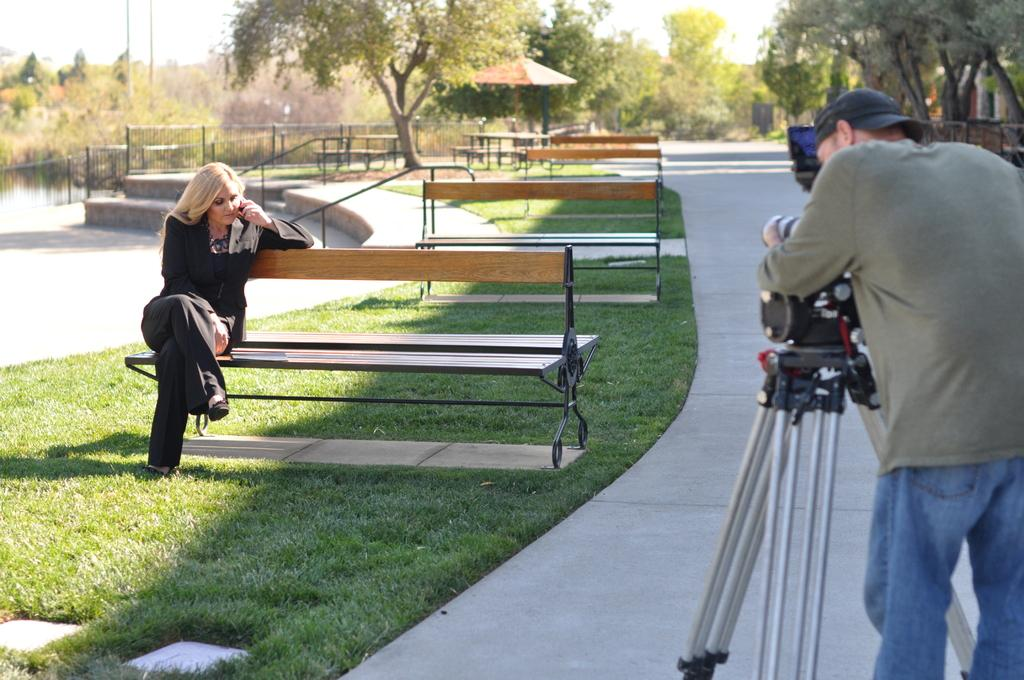What type of vegetation can be seen in the image? There are trees in the image. What type of seating is available in the image? There are benches in the image. What is the girl in the image doing? The girl is sitting in the image. What is the man in the image doing? The man is standing in the image and looking at the camera. Can you tell me how many jellyfish are swimming in the image? There are no jellyfish present in the image; it features trees, benches, a girl, and a man. What type of ear is visible on the girl in the image? There is no ear visible on the girl in the image, as it is a photograph of a girl sitting on a bench. 